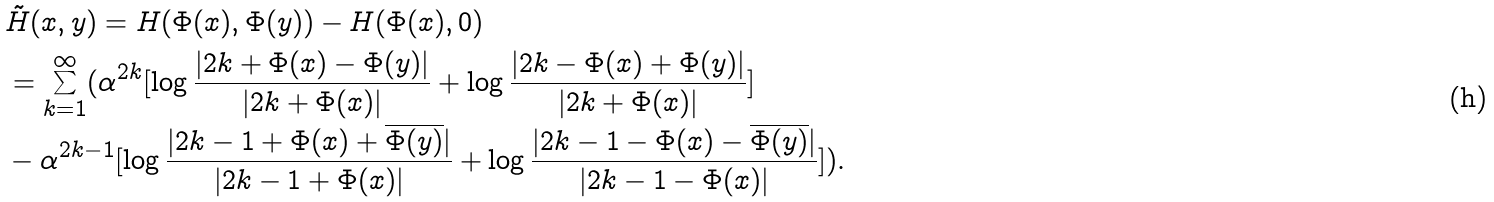<formula> <loc_0><loc_0><loc_500><loc_500>& \tilde { H } ( x , y ) = H ( \Phi ( x ) , \Phi ( y ) ) - H ( \Phi ( x ) , 0 ) \\ & = \sum _ { k = 1 } ^ { \infty } ( \alpha ^ { 2 k } [ \log \frac { | { 2 k } + \Phi ( x ) - \Phi ( y ) | } { | { 2 k } + \Phi ( x ) | } + \log \frac { | { 2 k } - \Phi ( x ) + \Phi ( y ) | } { | { 2 k } + \Phi ( x ) | } ] \\ & - \alpha ^ { 2 k - 1 } [ \log \frac { | { 2 k - 1 } + \Phi ( x ) + \overline { \Phi ( y ) } | } { | { 2 k - 1 } + \Phi ( x ) | } + \log \frac { | { 2 k - 1 } - \Phi ( x ) - \overline { \Phi ( y ) } | } { | { 2 k - 1 } - \Phi ( x ) | } ] ) .</formula> 